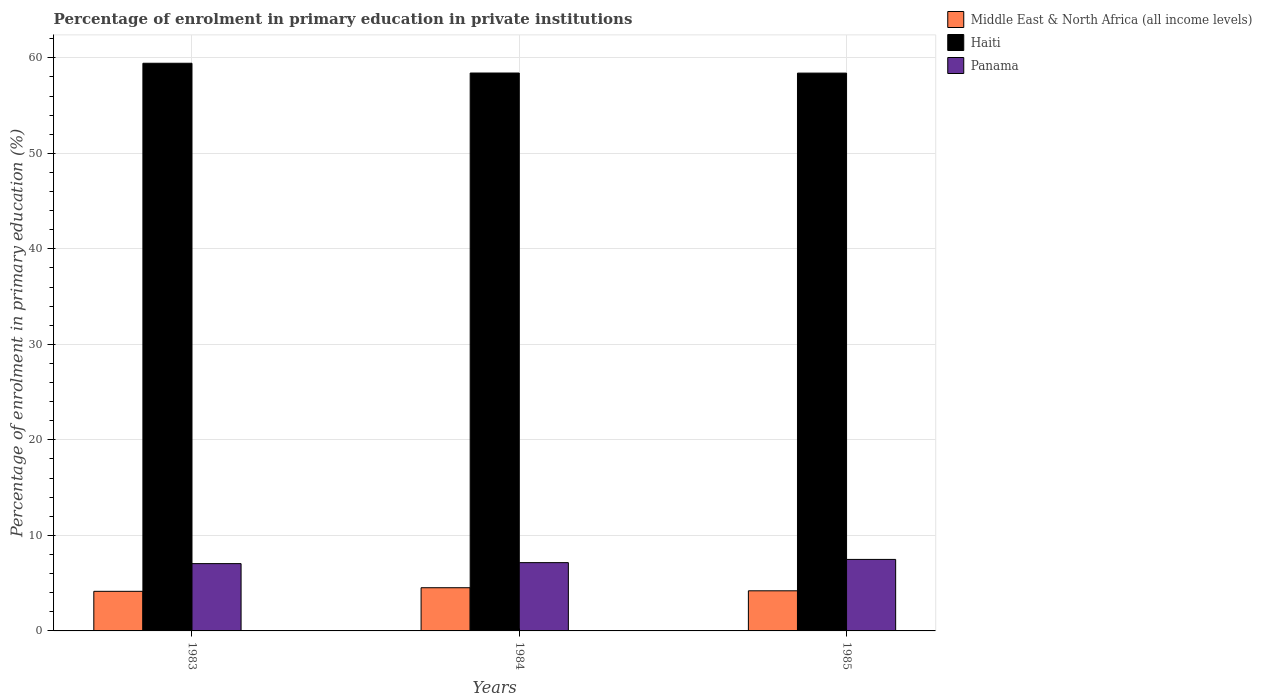Are the number of bars per tick equal to the number of legend labels?
Offer a terse response. Yes. How many bars are there on the 1st tick from the right?
Give a very brief answer. 3. What is the label of the 2nd group of bars from the left?
Your response must be concise. 1984. In how many cases, is the number of bars for a given year not equal to the number of legend labels?
Keep it short and to the point. 0. What is the percentage of enrolment in primary education in Middle East & North Africa (all income levels) in 1984?
Give a very brief answer. 4.52. Across all years, what is the maximum percentage of enrolment in primary education in Middle East & North Africa (all income levels)?
Make the answer very short. 4.52. Across all years, what is the minimum percentage of enrolment in primary education in Middle East & North Africa (all income levels)?
Your answer should be very brief. 4.15. In which year was the percentage of enrolment in primary education in Panama minimum?
Your response must be concise. 1983. What is the total percentage of enrolment in primary education in Middle East & North Africa (all income levels) in the graph?
Ensure brevity in your answer.  12.87. What is the difference between the percentage of enrolment in primary education in Middle East & North Africa (all income levels) in 1983 and that in 1985?
Offer a very short reply. -0.05. What is the difference between the percentage of enrolment in primary education in Haiti in 1985 and the percentage of enrolment in primary education in Panama in 1984?
Offer a very short reply. 51.25. What is the average percentage of enrolment in primary education in Panama per year?
Make the answer very short. 7.23. In the year 1983, what is the difference between the percentage of enrolment in primary education in Middle East & North Africa (all income levels) and percentage of enrolment in primary education in Panama?
Give a very brief answer. -2.9. In how many years, is the percentage of enrolment in primary education in Haiti greater than 54 %?
Offer a very short reply. 3. What is the ratio of the percentage of enrolment in primary education in Middle East & North Africa (all income levels) in 1984 to that in 1985?
Provide a short and direct response. 1.08. Is the difference between the percentage of enrolment in primary education in Middle East & North Africa (all income levels) in 1983 and 1984 greater than the difference between the percentage of enrolment in primary education in Panama in 1983 and 1984?
Your response must be concise. No. What is the difference between the highest and the second highest percentage of enrolment in primary education in Middle East & North Africa (all income levels)?
Keep it short and to the point. 0.32. What is the difference between the highest and the lowest percentage of enrolment in primary education in Panama?
Give a very brief answer. 0.44. Is the sum of the percentage of enrolment in primary education in Panama in 1983 and 1985 greater than the maximum percentage of enrolment in primary education in Haiti across all years?
Keep it short and to the point. No. What does the 2nd bar from the left in 1984 represents?
Make the answer very short. Haiti. What does the 1st bar from the right in 1985 represents?
Make the answer very short. Panama. Is it the case that in every year, the sum of the percentage of enrolment in primary education in Haiti and percentage of enrolment in primary education in Middle East & North Africa (all income levels) is greater than the percentage of enrolment in primary education in Panama?
Provide a succinct answer. Yes. How many years are there in the graph?
Provide a succinct answer. 3. What is the title of the graph?
Offer a very short reply. Percentage of enrolment in primary education in private institutions. Does "Guam" appear as one of the legend labels in the graph?
Your answer should be very brief. No. What is the label or title of the X-axis?
Provide a short and direct response. Years. What is the label or title of the Y-axis?
Your answer should be very brief. Percentage of enrolment in primary education (%). What is the Percentage of enrolment in primary education (%) of Middle East & North Africa (all income levels) in 1983?
Offer a very short reply. 4.15. What is the Percentage of enrolment in primary education (%) of Haiti in 1983?
Your response must be concise. 59.43. What is the Percentage of enrolment in primary education (%) of Panama in 1983?
Your answer should be very brief. 7.05. What is the Percentage of enrolment in primary education (%) in Middle East & North Africa (all income levels) in 1984?
Give a very brief answer. 4.52. What is the Percentage of enrolment in primary education (%) of Haiti in 1984?
Ensure brevity in your answer.  58.41. What is the Percentage of enrolment in primary education (%) in Panama in 1984?
Provide a short and direct response. 7.15. What is the Percentage of enrolment in primary education (%) of Middle East & North Africa (all income levels) in 1985?
Make the answer very short. 4.2. What is the Percentage of enrolment in primary education (%) in Haiti in 1985?
Make the answer very short. 58.4. What is the Percentage of enrolment in primary education (%) in Panama in 1985?
Provide a short and direct response. 7.49. Across all years, what is the maximum Percentage of enrolment in primary education (%) in Middle East & North Africa (all income levels)?
Provide a short and direct response. 4.52. Across all years, what is the maximum Percentage of enrolment in primary education (%) of Haiti?
Ensure brevity in your answer.  59.43. Across all years, what is the maximum Percentage of enrolment in primary education (%) in Panama?
Ensure brevity in your answer.  7.49. Across all years, what is the minimum Percentage of enrolment in primary education (%) in Middle East & North Africa (all income levels)?
Give a very brief answer. 4.15. Across all years, what is the minimum Percentage of enrolment in primary education (%) of Haiti?
Your response must be concise. 58.4. Across all years, what is the minimum Percentage of enrolment in primary education (%) in Panama?
Provide a succinct answer. 7.05. What is the total Percentage of enrolment in primary education (%) of Middle East & North Africa (all income levels) in the graph?
Provide a succinct answer. 12.87. What is the total Percentage of enrolment in primary education (%) in Haiti in the graph?
Provide a short and direct response. 176.24. What is the total Percentage of enrolment in primary education (%) of Panama in the graph?
Provide a succinct answer. 21.68. What is the difference between the Percentage of enrolment in primary education (%) in Middle East & North Africa (all income levels) in 1983 and that in 1984?
Give a very brief answer. -0.38. What is the difference between the Percentage of enrolment in primary education (%) in Haiti in 1983 and that in 1984?
Your answer should be very brief. 1.02. What is the difference between the Percentage of enrolment in primary education (%) of Panama in 1983 and that in 1984?
Ensure brevity in your answer.  -0.1. What is the difference between the Percentage of enrolment in primary education (%) in Middle East & North Africa (all income levels) in 1983 and that in 1985?
Provide a succinct answer. -0.05. What is the difference between the Percentage of enrolment in primary education (%) in Haiti in 1983 and that in 1985?
Offer a terse response. 1.03. What is the difference between the Percentage of enrolment in primary education (%) of Panama in 1983 and that in 1985?
Your response must be concise. -0.44. What is the difference between the Percentage of enrolment in primary education (%) in Middle East & North Africa (all income levels) in 1984 and that in 1985?
Ensure brevity in your answer.  0.32. What is the difference between the Percentage of enrolment in primary education (%) in Haiti in 1984 and that in 1985?
Your answer should be compact. 0.01. What is the difference between the Percentage of enrolment in primary education (%) in Panama in 1984 and that in 1985?
Give a very brief answer. -0.34. What is the difference between the Percentage of enrolment in primary education (%) in Middle East & North Africa (all income levels) in 1983 and the Percentage of enrolment in primary education (%) in Haiti in 1984?
Keep it short and to the point. -54.26. What is the difference between the Percentage of enrolment in primary education (%) of Middle East & North Africa (all income levels) in 1983 and the Percentage of enrolment in primary education (%) of Panama in 1984?
Your response must be concise. -3. What is the difference between the Percentage of enrolment in primary education (%) of Haiti in 1983 and the Percentage of enrolment in primary education (%) of Panama in 1984?
Keep it short and to the point. 52.28. What is the difference between the Percentage of enrolment in primary education (%) in Middle East & North Africa (all income levels) in 1983 and the Percentage of enrolment in primary education (%) in Haiti in 1985?
Your response must be concise. -54.25. What is the difference between the Percentage of enrolment in primary education (%) in Middle East & North Africa (all income levels) in 1983 and the Percentage of enrolment in primary education (%) in Panama in 1985?
Offer a very short reply. -3.34. What is the difference between the Percentage of enrolment in primary education (%) of Haiti in 1983 and the Percentage of enrolment in primary education (%) of Panama in 1985?
Ensure brevity in your answer.  51.94. What is the difference between the Percentage of enrolment in primary education (%) in Middle East & North Africa (all income levels) in 1984 and the Percentage of enrolment in primary education (%) in Haiti in 1985?
Offer a terse response. -53.88. What is the difference between the Percentage of enrolment in primary education (%) of Middle East & North Africa (all income levels) in 1984 and the Percentage of enrolment in primary education (%) of Panama in 1985?
Make the answer very short. -2.96. What is the difference between the Percentage of enrolment in primary education (%) in Haiti in 1984 and the Percentage of enrolment in primary education (%) in Panama in 1985?
Your answer should be compact. 50.92. What is the average Percentage of enrolment in primary education (%) of Middle East & North Africa (all income levels) per year?
Keep it short and to the point. 4.29. What is the average Percentage of enrolment in primary education (%) of Haiti per year?
Provide a succinct answer. 58.75. What is the average Percentage of enrolment in primary education (%) in Panama per year?
Provide a succinct answer. 7.23. In the year 1983, what is the difference between the Percentage of enrolment in primary education (%) in Middle East & North Africa (all income levels) and Percentage of enrolment in primary education (%) in Haiti?
Your answer should be very brief. -55.29. In the year 1983, what is the difference between the Percentage of enrolment in primary education (%) in Haiti and Percentage of enrolment in primary education (%) in Panama?
Ensure brevity in your answer.  52.39. In the year 1984, what is the difference between the Percentage of enrolment in primary education (%) in Middle East & North Africa (all income levels) and Percentage of enrolment in primary education (%) in Haiti?
Keep it short and to the point. -53.89. In the year 1984, what is the difference between the Percentage of enrolment in primary education (%) of Middle East & North Africa (all income levels) and Percentage of enrolment in primary education (%) of Panama?
Keep it short and to the point. -2.63. In the year 1984, what is the difference between the Percentage of enrolment in primary education (%) in Haiti and Percentage of enrolment in primary education (%) in Panama?
Your answer should be very brief. 51.26. In the year 1985, what is the difference between the Percentage of enrolment in primary education (%) of Middle East & North Africa (all income levels) and Percentage of enrolment in primary education (%) of Haiti?
Ensure brevity in your answer.  -54.2. In the year 1985, what is the difference between the Percentage of enrolment in primary education (%) of Middle East & North Africa (all income levels) and Percentage of enrolment in primary education (%) of Panama?
Ensure brevity in your answer.  -3.29. In the year 1985, what is the difference between the Percentage of enrolment in primary education (%) in Haiti and Percentage of enrolment in primary education (%) in Panama?
Make the answer very short. 50.91. What is the ratio of the Percentage of enrolment in primary education (%) of Middle East & North Africa (all income levels) in 1983 to that in 1984?
Keep it short and to the point. 0.92. What is the ratio of the Percentage of enrolment in primary education (%) of Haiti in 1983 to that in 1984?
Offer a very short reply. 1.02. What is the ratio of the Percentage of enrolment in primary education (%) of Panama in 1983 to that in 1984?
Offer a terse response. 0.99. What is the ratio of the Percentage of enrolment in primary education (%) of Middle East & North Africa (all income levels) in 1983 to that in 1985?
Give a very brief answer. 0.99. What is the ratio of the Percentage of enrolment in primary education (%) of Haiti in 1983 to that in 1985?
Offer a terse response. 1.02. What is the ratio of the Percentage of enrolment in primary education (%) in Panama in 1983 to that in 1985?
Your response must be concise. 0.94. What is the ratio of the Percentage of enrolment in primary education (%) of Middle East & North Africa (all income levels) in 1984 to that in 1985?
Offer a terse response. 1.08. What is the ratio of the Percentage of enrolment in primary education (%) of Panama in 1984 to that in 1985?
Offer a terse response. 0.95. What is the difference between the highest and the second highest Percentage of enrolment in primary education (%) in Middle East & North Africa (all income levels)?
Ensure brevity in your answer.  0.32. What is the difference between the highest and the second highest Percentage of enrolment in primary education (%) of Haiti?
Your answer should be very brief. 1.02. What is the difference between the highest and the second highest Percentage of enrolment in primary education (%) of Panama?
Offer a very short reply. 0.34. What is the difference between the highest and the lowest Percentage of enrolment in primary education (%) of Middle East & North Africa (all income levels)?
Your answer should be compact. 0.38. What is the difference between the highest and the lowest Percentage of enrolment in primary education (%) in Haiti?
Offer a terse response. 1.03. What is the difference between the highest and the lowest Percentage of enrolment in primary education (%) in Panama?
Keep it short and to the point. 0.44. 